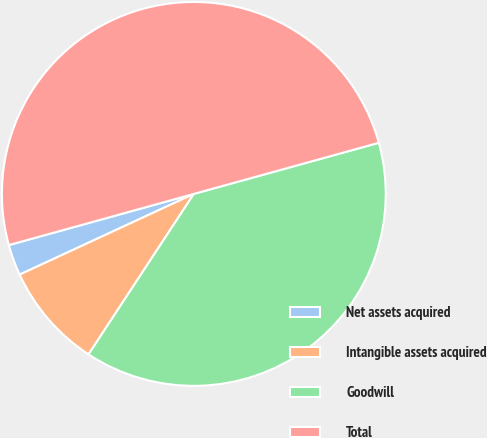<chart> <loc_0><loc_0><loc_500><loc_500><pie_chart><fcel>Net assets acquired<fcel>Intangible assets acquired<fcel>Goodwill<fcel>Total<nl><fcel>2.61%<fcel>8.85%<fcel>38.53%<fcel>50.0%<nl></chart> 